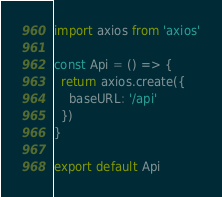Convert code to text. <code><loc_0><loc_0><loc_500><loc_500><_TypeScript_>import axios from 'axios'

const Api = () => {
  return axios.create({
    baseURL: '/api'
  })
}

export default Api
</code> 